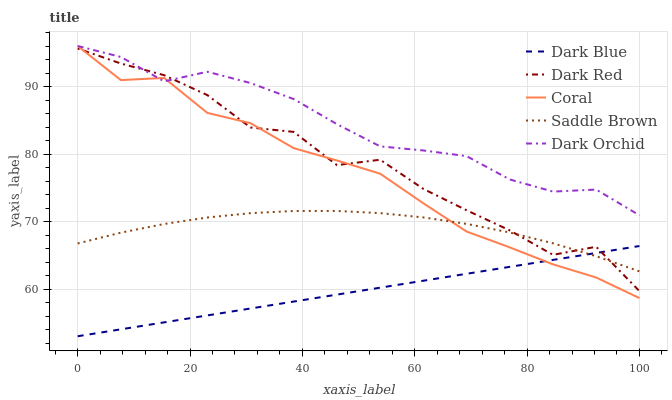Does Dark Blue have the minimum area under the curve?
Answer yes or no. Yes. Does Dark Orchid have the maximum area under the curve?
Answer yes or no. Yes. Does Coral have the minimum area under the curve?
Answer yes or no. No. Does Coral have the maximum area under the curve?
Answer yes or no. No. Is Dark Blue the smoothest?
Answer yes or no. Yes. Is Dark Red the roughest?
Answer yes or no. Yes. Is Coral the smoothest?
Answer yes or no. No. Is Coral the roughest?
Answer yes or no. No. Does Coral have the lowest value?
Answer yes or no. No. Does Saddle Brown have the highest value?
Answer yes or no. No. Is Saddle Brown less than Dark Orchid?
Answer yes or no. Yes. Is Dark Orchid greater than Dark Blue?
Answer yes or no. Yes. Does Saddle Brown intersect Dark Orchid?
Answer yes or no. No. 